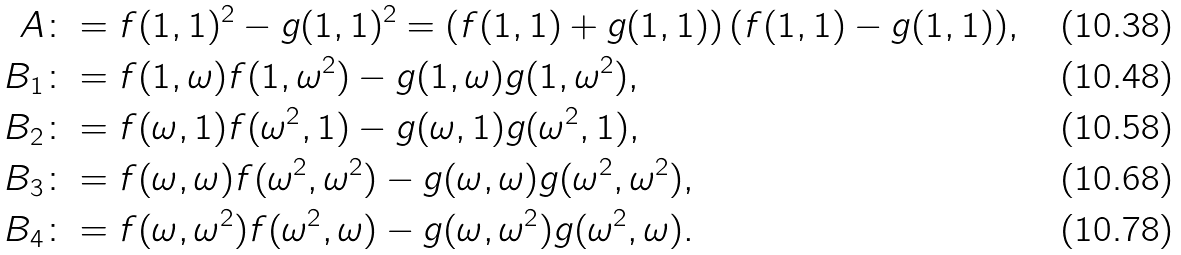Convert formula to latex. <formula><loc_0><loc_0><loc_500><loc_500>A \colon & = f ( 1 , 1 ) ^ { 2 } - g ( 1 , 1 ) ^ { 2 } = \left ( f ( 1 , 1 ) + g ( 1 , 1 ) \right ) ( f ( 1 , 1 ) - g ( 1 , 1 ) ) , \\ B _ { 1 } \colon & = f ( 1 , \omega ) f ( 1 , \omega ^ { 2 } ) - g ( 1 , \omega ) g ( 1 , \omega ^ { 2 } ) , \\ B _ { 2 } \colon & = f ( \omega , 1 ) f ( \omega ^ { 2 } , 1 ) - g ( \omega , 1 ) g ( \omega ^ { 2 } , 1 ) , \\ B _ { 3 } \colon & = f ( \omega , \omega ) f ( \omega ^ { 2 } , \omega ^ { 2 } ) - g ( \omega , \omega ) g ( \omega ^ { 2 } , \omega ^ { 2 } ) , \\ B _ { 4 } \colon & = f ( \omega , \omega ^ { 2 } ) f ( \omega ^ { 2 } , \omega ) - g ( \omega , \omega ^ { 2 } ) g ( \omega ^ { 2 } , \omega ) .</formula> 